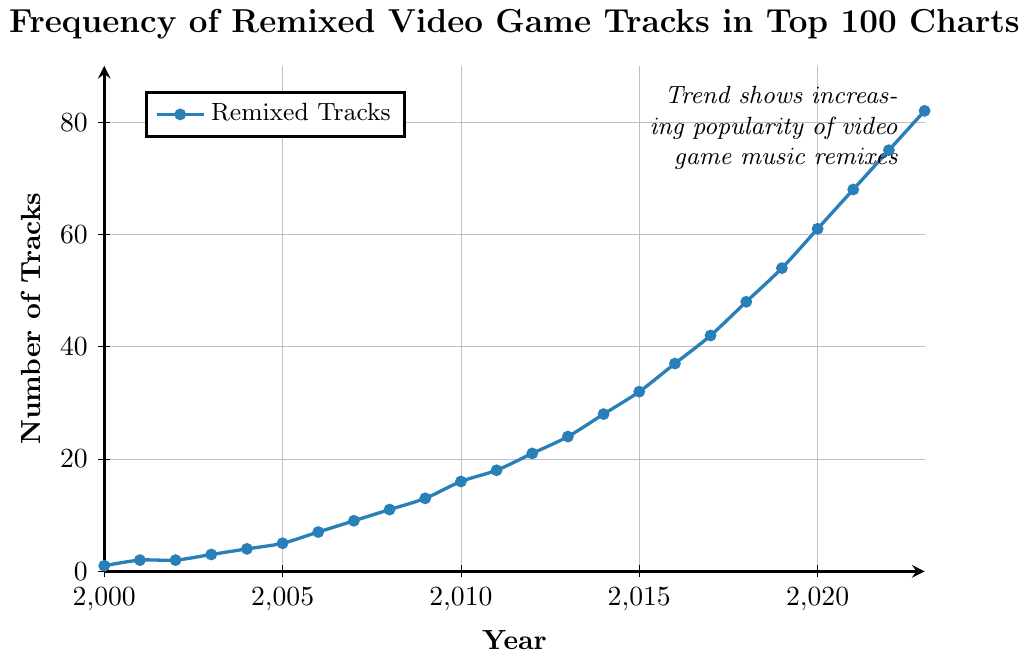What is the total number of remixed video game tracks in the top 100 charts in 2005 and 2010? To find the total number, add the number of tracks in 2005 and 2010 based on the figure. From the data, there are 5 tracks in 2005 and 16 tracks in 2010. Therefore, 5 + 16 = 21.
Answer: 21 Which year shows the highest increase in the number of remixed video game tracks compared to the previous year? Calculate the year-over-year increase for each year by subtracting the previous year's number of tracks from the current year. The largest difference is between 2022 and 2023, where it goes from 75 to 82, an increase of 7 tracks.
Answer: 2023 In which year did the number of remixed video game tracks first exceed 20? Look for the year where the number of tracks surpasses 20 for the first time. In 2012, the number of tracks is 21, which is the first year to exceed 20.
Answer: 2012 How many years did it take for the number of remixed video game tracks to go from 10 to 50? Identify the years when the number of tracks reached 10 and 50. It reached 11 in 2008 and 54 in 2019. Therefore, it took 2019 - 2008 = 11 years.
Answer: 11 years What is the average number of remixed video game tracks each year between 2010 and 2020? Add the number of tracks for each year from 2010 to 2020 and divide by the number of years (11). Sum = 16 + 18 + 21 + 24 + 28 + 32 + 37 + 42 + 48 + 54 + 61 = 381. So, the average is 381 / 11 = 34.64.
Answer: 34.64 Compare the number of remixed video game tracks in 2015 and 2020. Which year has more tracks, and by how much? Look at the figure and find the number of tracks in 2015 and 2020. In 2015, there are 32 tracks, and in 2020, there are 61 tracks. 2020 has more tracks by 61 - 32 = 29 tracks.
Answer: 2020, by 29 tracks What can you infer about the trend in the number of remixed video game tracks from 2000 to 2023? Observe the overall pattern in the figure. The number of remixed video game tracks increases steadily each year, showing a clear upward trend.
Answer: Increasing trend Identify the year where the slope of the increase in the number of tracks seems to steepen significantly. Examine the figure for a noticeable change in the steepness of the line. Between 2015 and 2016, the number of tracks increases significantly from 32 to 37, indicating a steeper slope.
Answer: 2016 